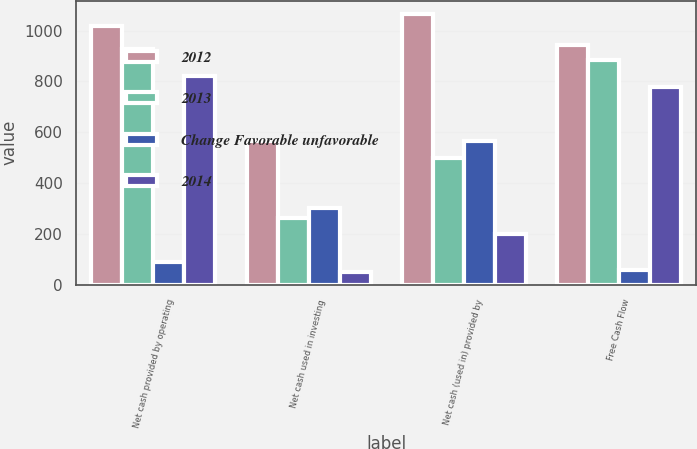<chart> <loc_0><loc_0><loc_500><loc_500><stacked_bar_chart><ecel><fcel>Net cash provided by operating<fcel>Net cash used in investing<fcel>Net cash (used in) provided by<fcel>Free Cash Flow<nl><fcel>2012<fcel>1018.6<fcel>564.9<fcel>1064.5<fcel>944<nl><fcel>2013<fcel>926.8<fcel>261.9<fcel>498.8<fcel>884.5<nl><fcel>Change Favorable unfavorable<fcel>91.8<fcel>303<fcel>565.7<fcel>59.5<nl><fcel>2014<fcel>823.1<fcel>50.2<fcel>202.6<fcel>778.1<nl></chart> 